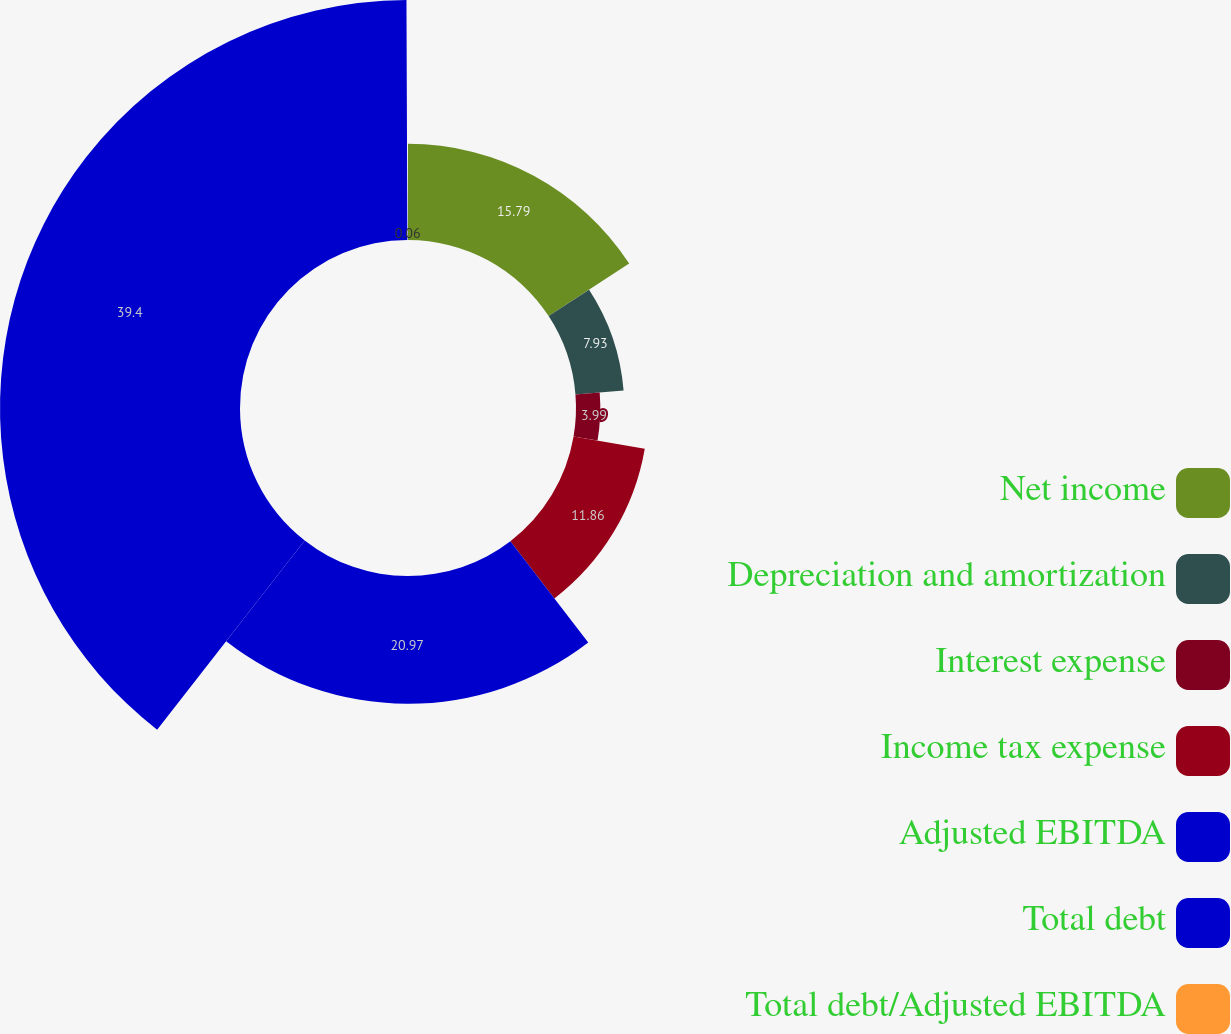Convert chart. <chart><loc_0><loc_0><loc_500><loc_500><pie_chart><fcel>Net income<fcel>Depreciation and amortization<fcel>Interest expense<fcel>Income tax expense<fcel>Adjusted EBITDA<fcel>Total debt<fcel>Total debt/Adjusted EBITDA<nl><fcel>15.79%<fcel>7.93%<fcel>3.99%<fcel>11.86%<fcel>20.97%<fcel>39.4%<fcel>0.06%<nl></chart> 